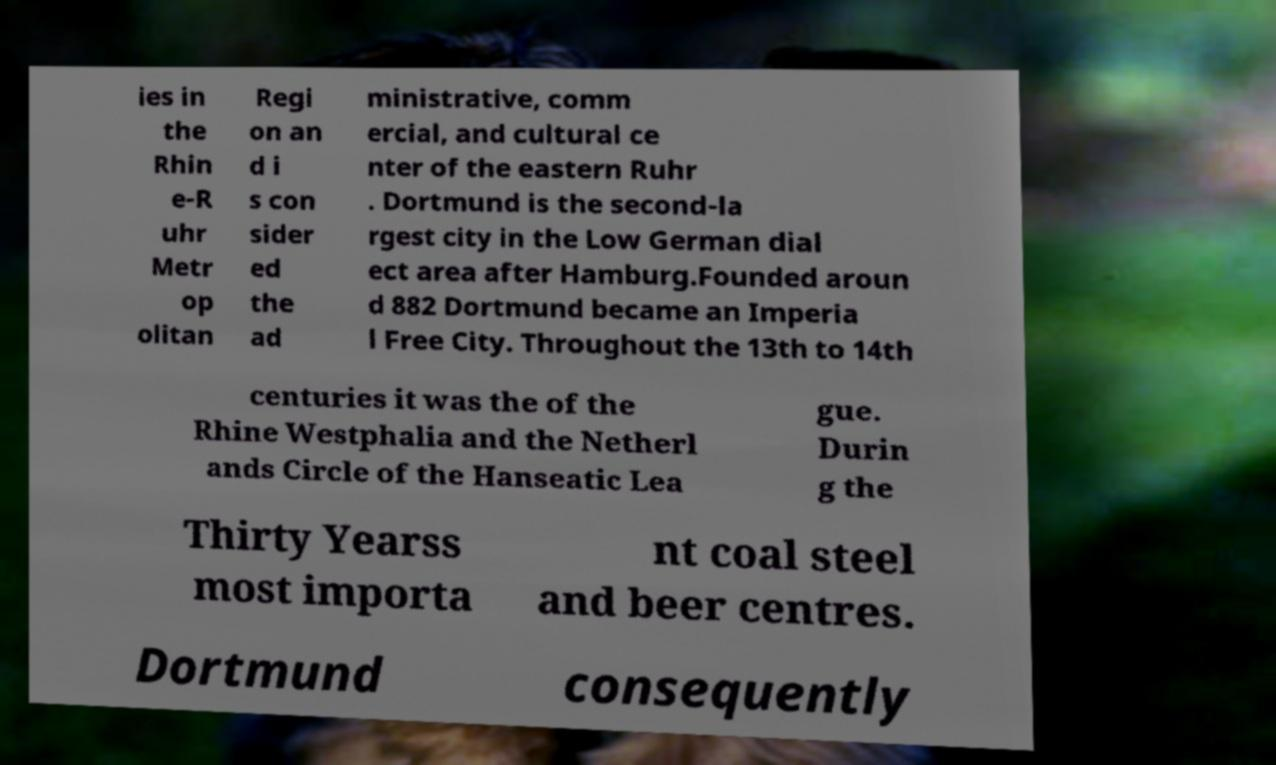What messages or text are displayed in this image? I need them in a readable, typed format. ies in the Rhin e-R uhr Metr op olitan Regi on an d i s con sider ed the ad ministrative, comm ercial, and cultural ce nter of the eastern Ruhr . Dortmund is the second-la rgest city in the Low German dial ect area after Hamburg.Founded aroun d 882 Dortmund became an Imperia l Free City. Throughout the 13th to 14th centuries it was the of the Rhine Westphalia and the Netherl ands Circle of the Hanseatic Lea gue. Durin g the Thirty Yearss most importa nt coal steel and beer centres. Dortmund consequently 